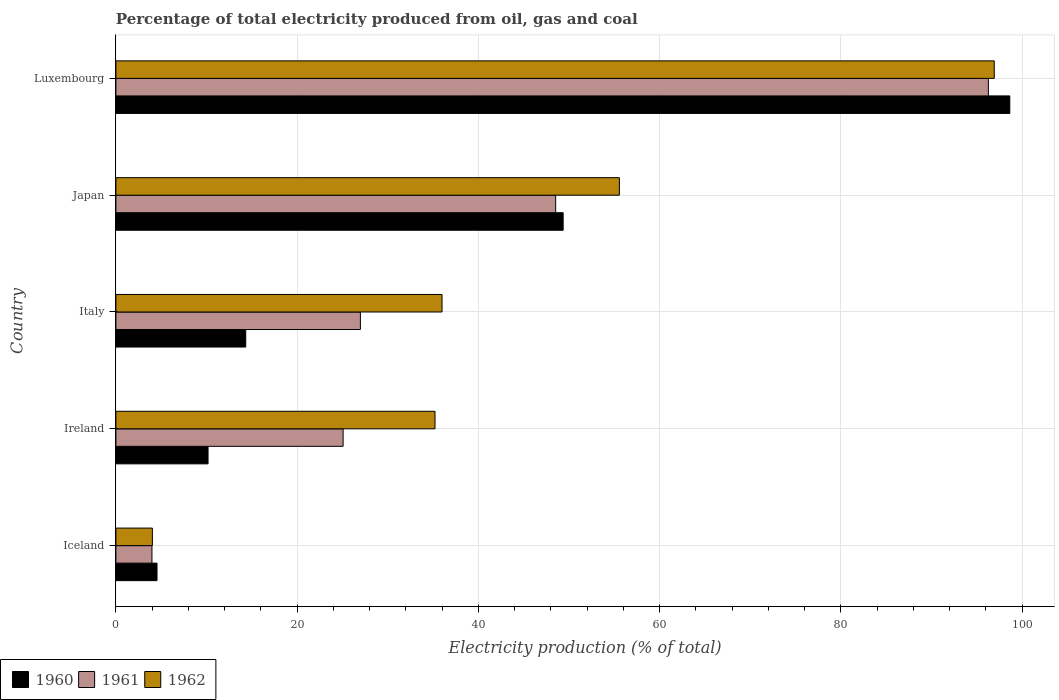Are the number of bars per tick equal to the number of legend labels?
Offer a terse response. Yes. How many bars are there on the 1st tick from the top?
Offer a terse response. 3. How many bars are there on the 5th tick from the bottom?
Provide a short and direct response. 3. In how many cases, is the number of bars for a given country not equal to the number of legend labels?
Offer a very short reply. 0. What is the electricity production in in 1960 in Italy?
Give a very brief answer. 14.33. Across all countries, what is the maximum electricity production in in 1960?
Provide a succinct answer. 98.63. Across all countries, what is the minimum electricity production in in 1962?
Offer a very short reply. 4.03. In which country was the electricity production in in 1960 maximum?
Make the answer very short. Luxembourg. In which country was the electricity production in in 1961 minimum?
Offer a terse response. Iceland. What is the total electricity production in in 1961 in the graph?
Offer a terse response. 200.82. What is the difference between the electricity production in in 1961 in Iceland and that in Japan?
Make the answer very short. -44.54. What is the difference between the electricity production in in 1960 in Luxembourg and the electricity production in in 1962 in Japan?
Provide a short and direct response. 43.08. What is the average electricity production in in 1962 per country?
Make the answer very short. 45.54. What is the difference between the electricity production in in 1961 and electricity production in in 1962 in Japan?
Make the answer very short. -7.03. What is the ratio of the electricity production in in 1961 in Ireland to that in Italy?
Your answer should be compact. 0.93. Is the electricity production in in 1960 in Japan less than that in Luxembourg?
Give a very brief answer. Yes. Is the difference between the electricity production in in 1961 in Japan and Luxembourg greater than the difference between the electricity production in in 1962 in Japan and Luxembourg?
Your answer should be very brief. No. What is the difference between the highest and the second highest electricity production in in 1960?
Keep it short and to the point. 49.28. What is the difference between the highest and the lowest electricity production in in 1962?
Your answer should be very brief. 92.89. What does the 1st bar from the top in Italy represents?
Your answer should be very brief. 1962. Is it the case that in every country, the sum of the electricity production in in 1962 and electricity production in in 1960 is greater than the electricity production in in 1961?
Your response must be concise. Yes. Are all the bars in the graph horizontal?
Make the answer very short. Yes. Are the values on the major ticks of X-axis written in scientific E-notation?
Offer a very short reply. No. How many legend labels are there?
Give a very brief answer. 3. How are the legend labels stacked?
Keep it short and to the point. Horizontal. What is the title of the graph?
Make the answer very short. Percentage of total electricity produced from oil, gas and coal. Does "2012" appear as one of the legend labels in the graph?
Ensure brevity in your answer.  No. What is the label or title of the X-axis?
Your answer should be compact. Electricity production (% of total). What is the Electricity production (% of total) in 1960 in Iceland?
Provide a succinct answer. 4.54. What is the Electricity production (% of total) of 1961 in Iceland?
Offer a very short reply. 3.98. What is the Electricity production (% of total) of 1962 in Iceland?
Your answer should be compact. 4.03. What is the Electricity production (% of total) in 1960 in Ireland?
Give a very brief answer. 10.17. What is the Electricity production (% of total) of 1961 in Ireland?
Provide a succinct answer. 25.07. What is the Electricity production (% of total) of 1962 in Ireland?
Ensure brevity in your answer.  35.21. What is the Electricity production (% of total) of 1960 in Italy?
Provide a short and direct response. 14.33. What is the Electricity production (% of total) in 1961 in Italy?
Your answer should be compact. 26.98. What is the Electricity production (% of total) of 1962 in Italy?
Keep it short and to the point. 35.99. What is the Electricity production (% of total) in 1960 in Japan?
Ensure brevity in your answer.  49.35. What is the Electricity production (% of total) of 1961 in Japan?
Provide a succinct answer. 48.52. What is the Electricity production (% of total) in 1962 in Japan?
Provide a short and direct response. 55.56. What is the Electricity production (% of total) in 1960 in Luxembourg?
Keep it short and to the point. 98.63. What is the Electricity production (% of total) in 1961 in Luxembourg?
Offer a very short reply. 96.27. What is the Electricity production (% of total) of 1962 in Luxembourg?
Your answer should be very brief. 96.92. Across all countries, what is the maximum Electricity production (% of total) in 1960?
Offer a very short reply. 98.63. Across all countries, what is the maximum Electricity production (% of total) of 1961?
Offer a terse response. 96.27. Across all countries, what is the maximum Electricity production (% of total) in 1962?
Offer a very short reply. 96.92. Across all countries, what is the minimum Electricity production (% of total) of 1960?
Your answer should be compact. 4.54. Across all countries, what is the minimum Electricity production (% of total) of 1961?
Provide a succinct answer. 3.98. Across all countries, what is the minimum Electricity production (% of total) of 1962?
Your response must be concise. 4.03. What is the total Electricity production (% of total) of 1960 in the graph?
Offer a very short reply. 177.02. What is the total Electricity production (% of total) of 1961 in the graph?
Your response must be concise. 200.82. What is the total Electricity production (% of total) in 1962 in the graph?
Provide a succinct answer. 227.7. What is the difference between the Electricity production (% of total) in 1960 in Iceland and that in Ireland?
Make the answer very short. -5.63. What is the difference between the Electricity production (% of total) of 1961 in Iceland and that in Ireland?
Ensure brevity in your answer.  -21.09. What is the difference between the Electricity production (% of total) in 1962 in Iceland and that in Ireland?
Make the answer very short. -31.19. What is the difference between the Electricity production (% of total) in 1960 in Iceland and that in Italy?
Give a very brief answer. -9.79. What is the difference between the Electricity production (% of total) of 1961 in Iceland and that in Italy?
Provide a short and direct response. -23. What is the difference between the Electricity production (% of total) of 1962 in Iceland and that in Italy?
Your answer should be very brief. -31.96. What is the difference between the Electricity production (% of total) of 1960 in Iceland and that in Japan?
Provide a short and direct response. -44.81. What is the difference between the Electricity production (% of total) in 1961 in Iceland and that in Japan?
Provide a short and direct response. -44.54. What is the difference between the Electricity production (% of total) of 1962 in Iceland and that in Japan?
Your answer should be very brief. -51.53. What is the difference between the Electricity production (% of total) of 1960 in Iceland and that in Luxembourg?
Provide a succinct answer. -94.1. What is the difference between the Electricity production (% of total) in 1961 in Iceland and that in Luxembourg?
Your answer should be compact. -92.29. What is the difference between the Electricity production (% of total) in 1962 in Iceland and that in Luxembourg?
Your answer should be compact. -92.89. What is the difference between the Electricity production (% of total) in 1960 in Ireland and that in Italy?
Your answer should be very brief. -4.16. What is the difference between the Electricity production (% of total) in 1961 in Ireland and that in Italy?
Your response must be concise. -1.91. What is the difference between the Electricity production (% of total) in 1962 in Ireland and that in Italy?
Your answer should be very brief. -0.78. What is the difference between the Electricity production (% of total) of 1960 in Ireland and that in Japan?
Ensure brevity in your answer.  -39.18. What is the difference between the Electricity production (% of total) of 1961 in Ireland and that in Japan?
Your answer should be very brief. -23.45. What is the difference between the Electricity production (% of total) in 1962 in Ireland and that in Japan?
Offer a very short reply. -20.34. What is the difference between the Electricity production (% of total) in 1960 in Ireland and that in Luxembourg?
Keep it short and to the point. -88.47. What is the difference between the Electricity production (% of total) in 1961 in Ireland and that in Luxembourg?
Keep it short and to the point. -71.2. What is the difference between the Electricity production (% of total) in 1962 in Ireland and that in Luxembourg?
Make the answer very short. -61.71. What is the difference between the Electricity production (% of total) of 1960 in Italy and that in Japan?
Make the answer very short. -35.02. What is the difference between the Electricity production (% of total) of 1961 in Italy and that in Japan?
Your answer should be compact. -21.55. What is the difference between the Electricity production (% of total) in 1962 in Italy and that in Japan?
Your response must be concise. -19.57. What is the difference between the Electricity production (% of total) of 1960 in Italy and that in Luxembourg?
Offer a very short reply. -84.31. What is the difference between the Electricity production (% of total) in 1961 in Italy and that in Luxembourg?
Your response must be concise. -69.29. What is the difference between the Electricity production (% of total) in 1962 in Italy and that in Luxembourg?
Give a very brief answer. -60.93. What is the difference between the Electricity production (% of total) in 1960 in Japan and that in Luxembourg?
Your answer should be compact. -49.28. What is the difference between the Electricity production (% of total) of 1961 in Japan and that in Luxembourg?
Keep it short and to the point. -47.75. What is the difference between the Electricity production (% of total) of 1962 in Japan and that in Luxembourg?
Make the answer very short. -41.36. What is the difference between the Electricity production (% of total) of 1960 in Iceland and the Electricity production (% of total) of 1961 in Ireland?
Keep it short and to the point. -20.53. What is the difference between the Electricity production (% of total) in 1960 in Iceland and the Electricity production (% of total) in 1962 in Ireland?
Make the answer very short. -30.67. What is the difference between the Electricity production (% of total) of 1961 in Iceland and the Electricity production (% of total) of 1962 in Ireland?
Your answer should be compact. -31.23. What is the difference between the Electricity production (% of total) of 1960 in Iceland and the Electricity production (% of total) of 1961 in Italy?
Provide a short and direct response. -22.44. What is the difference between the Electricity production (% of total) of 1960 in Iceland and the Electricity production (% of total) of 1962 in Italy?
Offer a terse response. -31.45. What is the difference between the Electricity production (% of total) of 1961 in Iceland and the Electricity production (% of total) of 1962 in Italy?
Your response must be concise. -32.01. What is the difference between the Electricity production (% of total) of 1960 in Iceland and the Electricity production (% of total) of 1961 in Japan?
Provide a short and direct response. -43.99. What is the difference between the Electricity production (% of total) in 1960 in Iceland and the Electricity production (% of total) in 1962 in Japan?
Offer a terse response. -51.02. What is the difference between the Electricity production (% of total) of 1961 in Iceland and the Electricity production (% of total) of 1962 in Japan?
Your answer should be compact. -51.58. What is the difference between the Electricity production (% of total) of 1960 in Iceland and the Electricity production (% of total) of 1961 in Luxembourg?
Your response must be concise. -91.73. What is the difference between the Electricity production (% of total) of 1960 in Iceland and the Electricity production (% of total) of 1962 in Luxembourg?
Your response must be concise. -92.38. What is the difference between the Electricity production (% of total) in 1961 in Iceland and the Electricity production (% of total) in 1962 in Luxembourg?
Make the answer very short. -92.94. What is the difference between the Electricity production (% of total) of 1960 in Ireland and the Electricity production (% of total) of 1961 in Italy?
Keep it short and to the point. -16.81. What is the difference between the Electricity production (% of total) of 1960 in Ireland and the Electricity production (% of total) of 1962 in Italy?
Your answer should be compact. -25.82. What is the difference between the Electricity production (% of total) of 1961 in Ireland and the Electricity production (% of total) of 1962 in Italy?
Provide a short and direct response. -10.92. What is the difference between the Electricity production (% of total) in 1960 in Ireland and the Electricity production (% of total) in 1961 in Japan?
Your answer should be very brief. -38.36. What is the difference between the Electricity production (% of total) of 1960 in Ireland and the Electricity production (% of total) of 1962 in Japan?
Your answer should be very brief. -45.39. What is the difference between the Electricity production (% of total) in 1961 in Ireland and the Electricity production (% of total) in 1962 in Japan?
Your response must be concise. -30.48. What is the difference between the Electricity production (% of total) in 1960 in Ireland and the Electricity production (% of total) in 1961 in Luxembourg?
Offer a terse response. -86.1. What is the difference between the Electricity production (% of total) of 1960 in Ireland and the Electricity production (% of total) of 1962 in Luxembourg?
Ensure brevity in your answer.  -86.75. What is the difference between the Electricity production (% of total) of 1961 in Ireland and the Electricity production (% of total) of 1962 in Luxembourg?
Give a very brief answer. -71.85. What is the difference between the Electricity production (% of total) in 1960 in Italy and the Electricity production (% of total) in 1961 in Japan?
Offer a terse response. -34.2. What is the difference between the Electricity production (% of total) in 1960 in Italy and the Electricity production (% of total) in 1962 in Japan?
Offer a very short reply. -41.23. What is the difference between the Electricity production (% of total) in 1961 in Italy and the Electricity production (% of total) in 1962 in Japan?
Give a very brief answer. -28.58. What is the difference between the Electricity production (% of total) in 1960 in Italy and the Electricity production (% of total) in 1961 in Luxembourg?
Give a very brief answer. -81.94. What is the difference between the Electricity production (% of total) of 1960 in Italy and the Electricity production (% of total) of 1962 in Luxembourg?
Ensure brevity in your answer.  -82.59. What is the difference between the Electricity production (% of total) of 1961 in Italy and the Electricity production (% of total) of 1962 in Luxembourg?
Give a very brief answer. -69.94. What is the difference between the Electricity production (% of total) of 1960 in Japan and the Electricity production (% of total) of 1961 in Luxembourg?
Give a very brief answer. -46.92. What is the difference between the Electricity production (% of total) in 1960 in Japan and the Electricity production (% of total) in 1962 in Luxembourg?
Offer a very short reply. -47.57. What is the difference between the Electricity production (% of total) in 1961 in Japan and the Electricity production (% of total) in 1962 in Luxembourg?
Keep it short and to the point. -48.39. What is the average Electricity production (% of total) of 1960 per country?
Your response must be concise. 35.4. What is the average Electricity production (% of total) in 1961 per country?
Your answer should be compact. 40.16. What is the average Electricity production (% of total) of 1962 per country?
Your response must be concise. 45.54. What is the difference between the Electricity production (% of total) in 1960 and Electricity production (% of total) in 1961 in Iceland?
Offer a very short reply. 0.56. What is the difference between the Electricity production (% of total) in 1960 and Electricity production (% of total) in 1962 in Iceland?
Offer a very short reply. 0.51. What is the difference between the Electricity production (% of total) in 1961 and Electricity production (% of total) in 1962 in Iceland?
Offer a very short reply. -0.05. What is the difference between the Electricity production (% of total) in 1960 and Electricity production (% of total) in 1961 in Ireland?
Your answer should be very brief. -14.9. What is the difference between the Electricity production (% of total) in 1960 and Electricity production (% of total) in 1962 in Ireland?
Offer a terse response. -25.04. What is the difference between the Electricity production (% of total) of 1961 and Electricity production (% of total) of 1962 in Ireland?
Keep it short and to the point. -10.14. What is the difference between the Electricity production (% of total) in 1960 and Electricity production (% of total) in 1961 in Italy?
Your response must be concise. -12.65. What is the difference between the Electricity production (% of total) of 1960 and Electricity production (% of total) of 1962 in Italy?
Your response must be concise. -21.66. What is the difference between the Electricity production (% of total) of 1961 and Electricity production (% of total) of 1962 in Italy?
Give a very brief answer. -9.01. What is the difference between the Electricity production (% of total) of 1960 and Electricity production (% of total) of 1961 in Japan?
Offer a terse response. 0.83. What is the difference between the Electricity production (% of total) in 1960 and Electricity production (% of total) in 1962 in Japan?
Provide a short and direct response. -6.2. What is the difference between the Electricity production (% of total) in 1961 and Electricity production (% of total) in 1962 in Japan?
Make the answer very short. -7.03. What is the difference between the Electricity production (% of total) of 1960 and Electricity production (% of total) of 1961 in Luxembourg?
Make the answer very short. 2.36. What is the difference between the Electricity production (% of total) in 1960 and Electricity production (% of total) in 1962 in Luxembourg?
Provide a succinct answer. 1.72. What is the difference between the Electricity production (% of total) of 1961 and Electricity production (% of total) of 1962 in Luxembourg?
Your response must be concise. -0.65. What is the ratio of the Electricity production (% of total) in 1960 in Iceland to that in Ireland?
Give a very brief answer. 0.45. What is the ratio of the Electricity production (% of total) of 1961 in Iceland to that in Ireland?
Ensure brevity in your answer.  0.16. What is the ratio of the Electricity production (% of total) in 1962 in Iceland to that in Ireland?
Offer a very short reply. 0.11. What is the ratio of the Electricity production (% of total) of 1960 in Iceland to that in Italy?
Provide a short and direct response. 0.32. What is the ratio of the Electricity production (% of total) of 1961 in Iceland to that in Italy?
Your answer should be compact. 0.15. What is the ratio of the Electricity production (% of total) in 1962 in Iceland to that in Italy?
Make the answer very short. 0.11. What is the ratio of the Electricity production (% of total) in 1960 in Iceland to that in Japan?
Give a very brief answer. 0.09. What is the ratio of the Electricity production (% of total) of 1961 in Iceland to that in Japan?
Offer a very short reply. 0.08. What is the ratio of the Electricity production (% of total) in 1962 in Iceland to that in Japan?
Provide a succinct answer. 0.07. What is the ratio of the Electricity production (% of total) in 1960 in Iceland to that in Luxembourg?
Keep it short and to the point. 0.05. What is the ratio of the Electricity production (% of total) of 1961 in Iceland to that in Luxembourg?
Give a very brief answer. 0.04. What is the ratio of the Electricity production (% of total) of 1962 in Iceland to that in Luxembourg?
Give a very brief answer. 0.04. What is the ratio of the Electricity production (% of total) of 1960 in Ireland to that in Italy?
Provide a succinct answer. 0.71. What is the ratio of the Electricity production (% of total) of 1961 in Ireland to that in Italy?
Provide a short and direct response. 0.93. What is the ratio of the Electricity production (% of total) in 1962 in Ireland to that in Italy?
Offer a very short reply. 0.98. What is the ratio of the Electricity production (% of total) of 1960 in Ireland to that in Japan?
Keep it short and to the point. 0.21. What is the ratio of the Electricity production (% of total) of 1961 in Ireland to that in Japan?
Offer a very short reply. 0.52. What is the ratio of the Electricity production (% of total) of 1962 in Ireland to that in Japan?
Provide a succinct answer. 0.63. What is the ratio of the Electricity production (% of total) in 1960 in Ireland to that in Luxembourg?
Give a very brief answer. 0.1. What is the ratio of the Electricity production (% of total) of 1961 in Ireland to that in Luxembourg?
Provide a short and direct response. 0.26. What is the ratio of the Electricity production (% of total) in 1962 in Ireland to that in Luxembourg?
Your response must be concise. 0.36. What is the ratio of the Electricity production (% of total) of 1960 in Italy to that in Japan?
Make the answer very short. 0.29. What is the ratio of the Electricity production (% of total) of 1961 in Italy to that in Japan?
Ensure brevity in your answer.  0.56. What is the ratio of the Electricity production (% of total) in 1962 in Italy to that in Japan?
Your answer should be compact. 0.65. What is the ratio of the Electricity production (% of total) in 1960 in Italy to that in Luxembourg?
Offer a very short reply. 0.15. What is the ratio of the Electricity production (% of total) of 1961 in Italy to that in Luxembourg?
Your response must be concise. 0.28. What is the ratio of the Electricity production (% of total) in 1962 in Italy to that in Luxembourg?
Your answer should be very brief. 0.37. What is the ratio of the Electricity production (% of total) of 1960 in Japan to that in Luxembourg?
Your answer should be compact. 0.5. What is the ratio of the Electricity production (% of total) of 1961 in Japan to that in Luxembourg?
Keep it short and to the point. 0.5. What is the ratio of the Electricity production (% of total) in 1962 in Japan to that in Luxembourg?
Your answer should be compact. 0.57. What is the difference between the highest and the second highest Electricity production (% of total) in 1960?
Your response must be concise. 49.28. What is the difference between the highest and the second highest Electricity production (% of total) in 1961?
Make the answer very short. 47.75. What is the difference between the highest and the second highest Electricity production (% of total) of 1962?
Your answer should be very brief. 41.36. What is the difference between the highest and the lowest Electricity production (% of total) in 1960?
Ensure brevity in your answer.  94.1. What is the difference between the highest and the lowest Electricity production (% of total) of 1961?
Ensure brevity in your answer.  92.29. What is the difference between the highest and the lowest Electricity production (% of total) of 1962?
Keep it short and to the point. 92.89. 